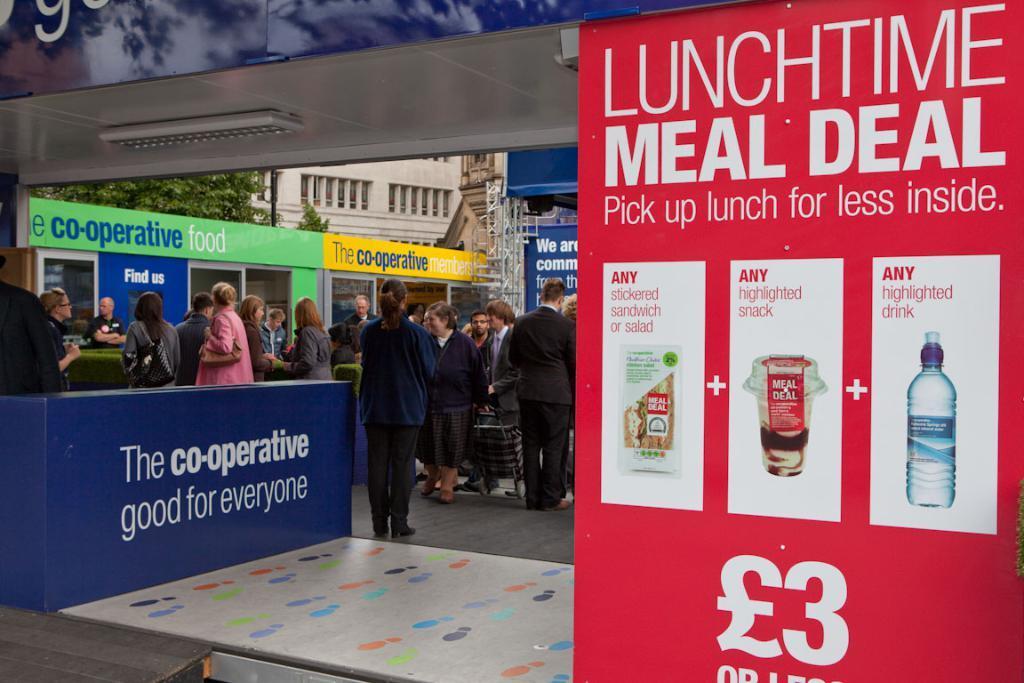In one or two sentences, can you explain what this image depicts? In this image we can see a red color banner. Beside so many men and women are standing. Background of the image building and tree is present. 